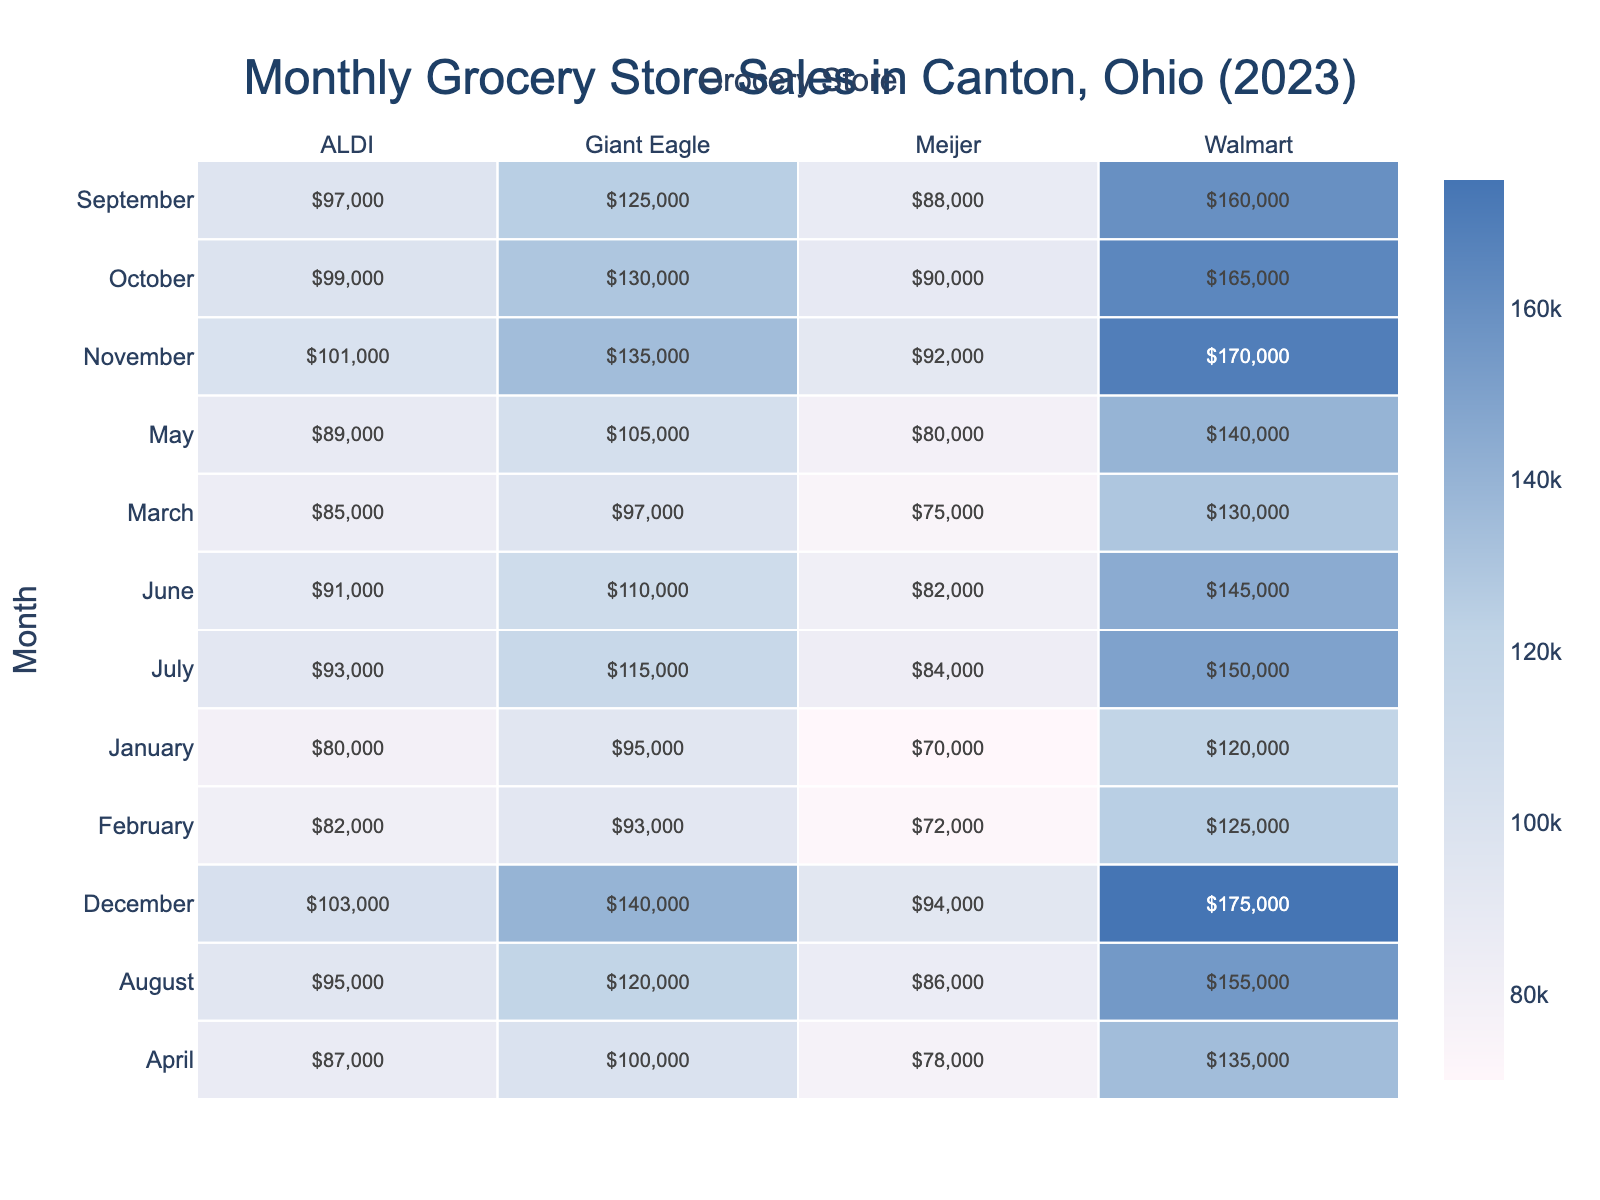What was the total sales for Walmart from January to March? To find the total sales for Walmart in January, February, and March, we look at the individual sales figures: January (120,000), February (125,000), and March (130,000). Adding these together: 120,000 + 125,000 + 130,000 = 375,000.
Answer: 375,000 Which grocery store had the highest sales in August? By observing the sales figures for August, Walmart has sales of 155,000, ALDI has 95,000, Giant Eagle has 120,000, and Meijer has 86,000. Among these, Walmart has the highest sales at 155,000.
Answer: Walmart What was the average sales for ALDI across the months? To find the average sales for ALDI, we first sum the sales for each month: 80,000 (Jan) + 82,000 (Feb) + 85,000 (Mar) + 87,000 (Apr) + 89,000 (May) + 91,000 (Jun) + 93,000 (Jul) + 95,000 (Aug) + 97,000 (Sep) + 99,000 (Oct) + 101,000 (Nov) + 103,000 (Dec) = 1,137,000. There are 12 months, so the average is 1,137,000 / 12 = 94,750.
Answer: 94,750 Did Meijer have more sales than Giant Eagle in any month? Looking at the monthly sales data, we compare Meijer and Giant Eagle. In January, Giant Eagle (95,000) was higher than Meijer (70,000); in February, Giant Eagle (93,000) was again higher than Meijer (72,000); this trend continues in March, April, May, June, July, August, September, October, November, and December. So, Giant Eagle always had more sales than Meijer.
Answer: No Which month saw a sales increase for ALDI compared to the previous month? To identify month-to-month sales increases for ALDI, we look at the sales figures: January (80,000), February (82,000), March (85,000), April (87,000), May (89,000), June (91,000), July (93,000), August (95,000), September (97,000), October (99,000), November (101,000), December (103,000). Every month shows an increase from the previous month for ALDI.
Answer: Every month What is the difference in sales between the highest and lowest sales month for Giant Eagle? The highest sales month for Giant Eagle was December (140,000) and the lowest was January (95,000). The difference is calculated as 140,000 - 95,000 = 45,000.
Answer: 45,000 What was the total customer count for Walmart from May to July? For Walmart, the customer counts are: May (5,000), June (5,100), and July (5,200). Summing these gives: 5,000 + 5,100 + 5,200 = 15,300.
Answer: 15,300 Which grocery store consistently had the least sales each month? By analyzing the sales for each grocery store across all months, we see that Meijer has the lowest sales figures in every month compared to Walmart, ALDI, and Giant Eagle.
Answer: Meijer 